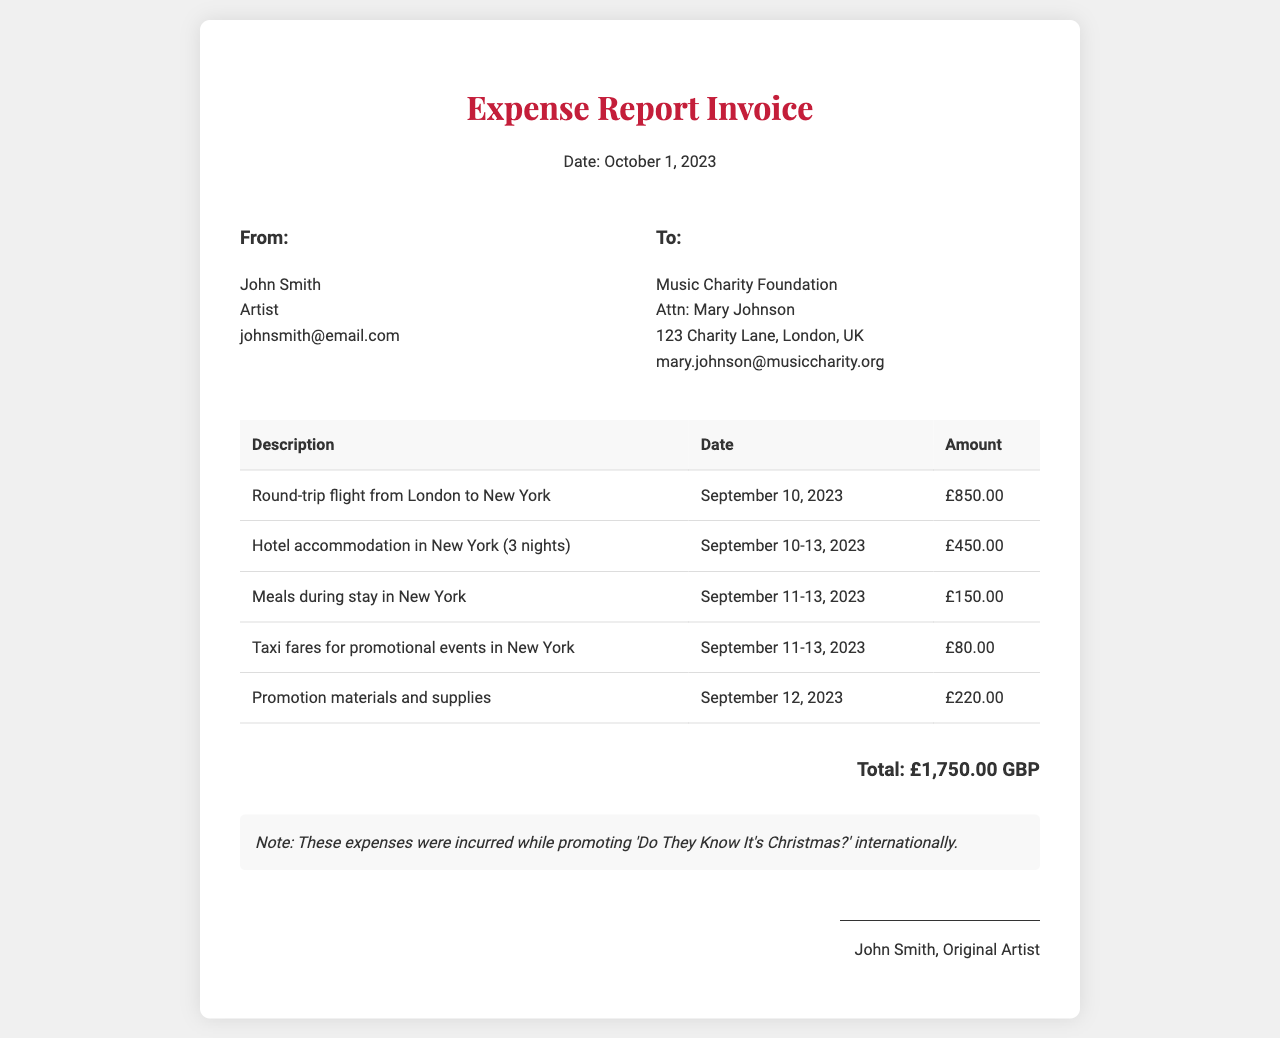what is the total amount of expenses? The total expenses listed in the invoice are summed up, which is £850.00 + £450.00 + £150.00 + £80.00 + £220.00.
Answer: £1,750.00 GBP who is the recipient of the invoice? The recipient's name and organization are provided in the document, specifically under the "To" section.
Answer: Music Charity Foundation when was the flight from London to New York? The date for the round-trip flight is specified in the document under the relevant description.
Answer: September 10, 2023 how many nights was the hotel stay? The duration of the hotel accommodation is detailed in the invoice, indicating the number of nights spent.
Answer: 3 nights who is the sender of the invoice? The sender's information is presented in the "From" section of the document.
Answer: John Smith what type of expenses were incurred during this trip? The document details different categories of expenses related to the trip for promoting the song.
Answer: Travel costs which city was the promotion conducted in? The document mentions the location of the promotional events related to the expenses.
Answer: New York how much was spent on meals? The expense for meals is specifically listed in the table of expenses within the document.
Answer: £150.00 what is the date of the invoice? The date of the invoice is mentioned prominently at the beginning of the document.
Answer: October 1, 2023 